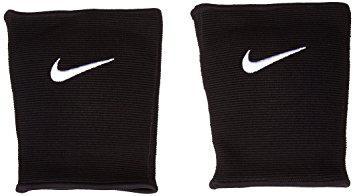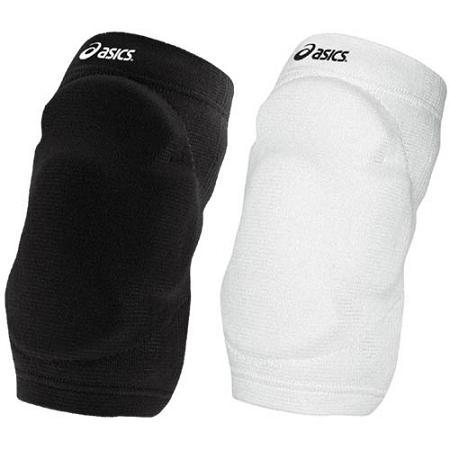The first image is the image on the left, the second image is the image on the right. For the images shown, is this caption "The white object is on the right side of the image in the image on the right." true? Answer yes or no. Yes. The first image is the image on the left, the second image is the image on the right. For the images displayed, is the sentence "Three pads are black and one is white." factually correct? Answer yes or no. Yes. 